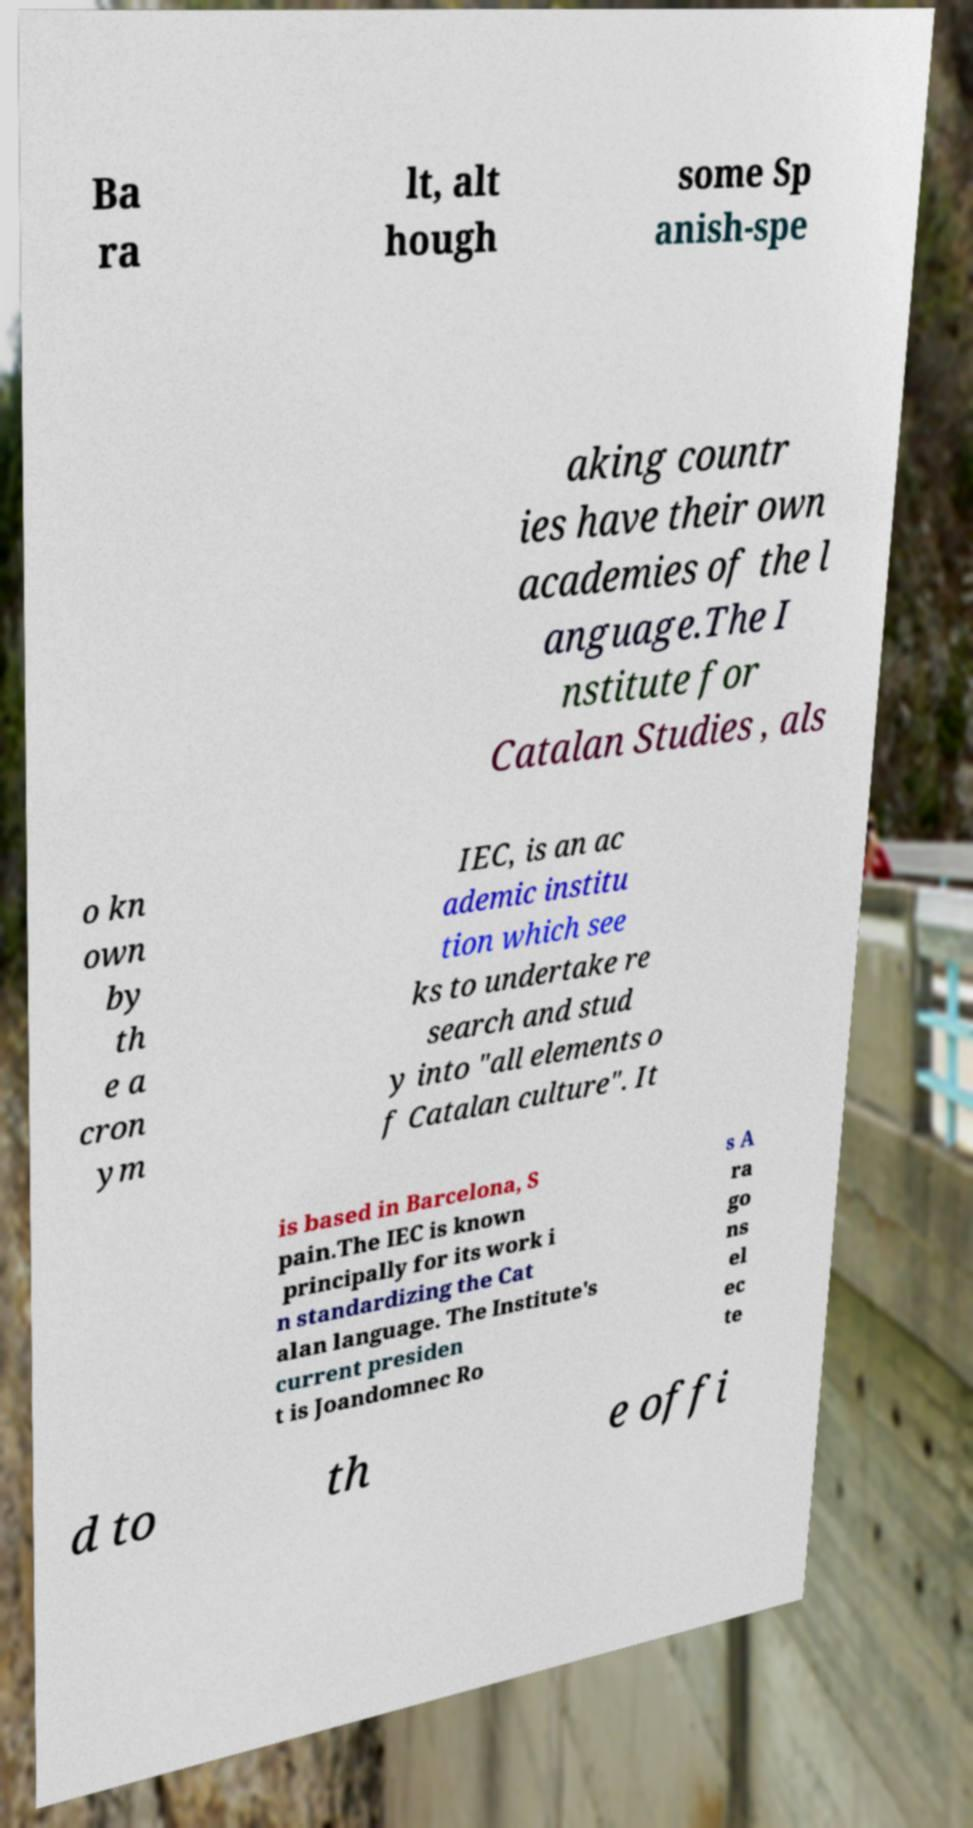Please identify and transcribe the text found in this image. Ba ra lt, alt hough some Sp anish-spe aking countr ies have their own academies of the l anguage.The I nstitute for Catalan Studies , als o kn own by th e a cron ym IEC, is an ac ademic institu tion which see ks to undertake re search and stud y into "all elements o f Catalan culture". It is based in Barcelona, S pain.The IEC is known principally for its work i n standardizing the Cat alan language. The Institute's current presiden t is Joandomnec Ro s A ra go ns el ec te d to th e offi 